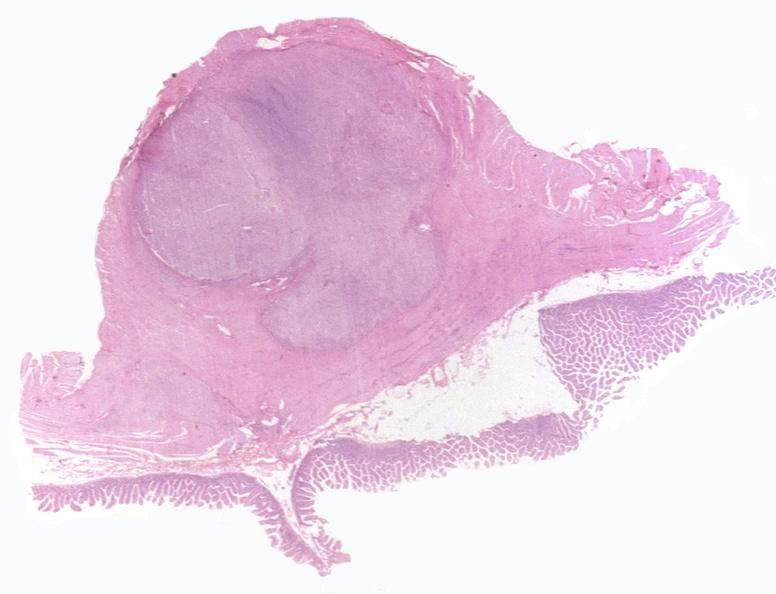does this image show intestine, leiomyoma?
Answer the question using a single word or phrase. Yes 